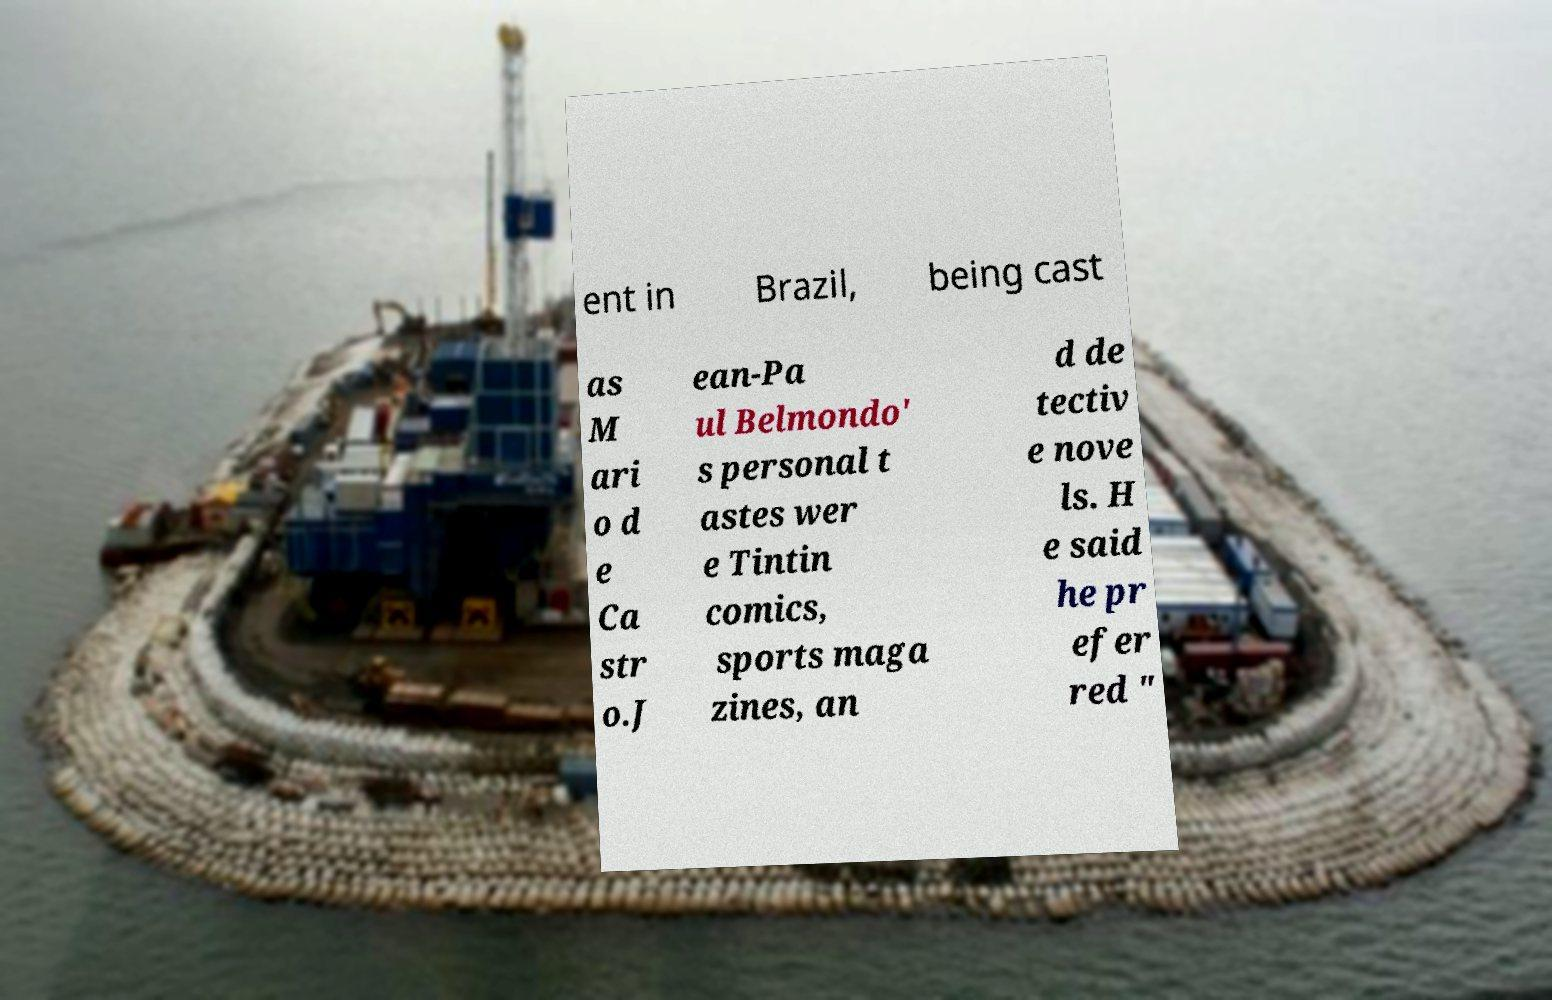Please identify and transcribe the text found in this image. ent in Brazil, being cast as M ari o d e Ca str o.J ean-Pa ul Belmondo' s personal t astes wer e Tintin comics, sports maga zines, an d de tectiv e nove ls. H e said he pr efer red " 